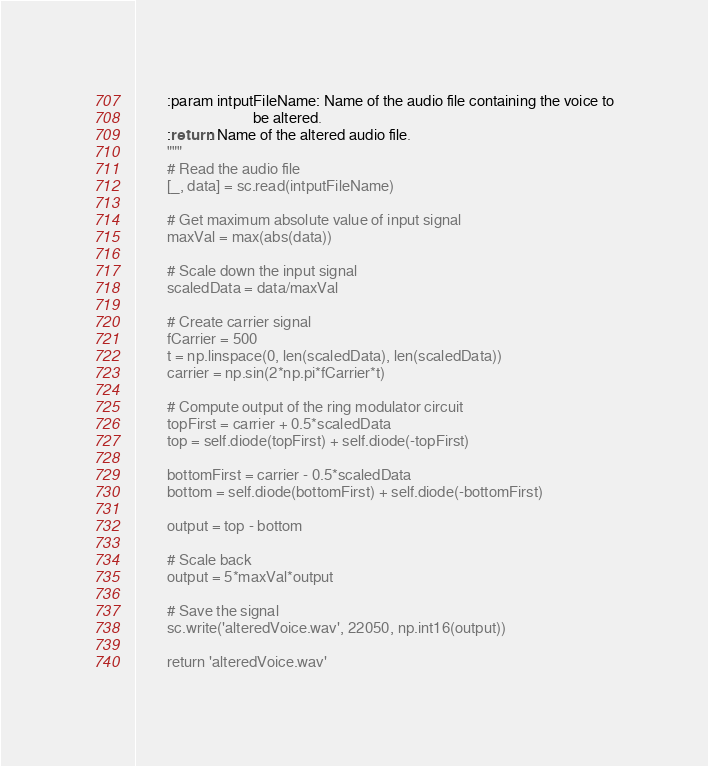Convert code to text. <code><loc_0><loc_0><loc_500><loc_500><_Python_>
        :param intputFileName: Name of the audio file containing the voice to
                               be altered.
        :return: Name of the altered audio file.
        """
        # Read the audio file
        [_, data] = sc.read(intputFileName)

        # Get maximum absolute value of input signal
        maxVal = max(abs(data))

        # Scale down the input signal
        scaledData = data/maxVal

        # Create carrier signal
        fCarrier = 500
        t = np.linspace(0, len(scaledData), len(scaledData))
        carrier = np.sin(2*np.pi*fCarrier*t)

        # Compute output of the ring modulator circuit
        topFirst = carrier + 0.5*scaledData
        top = self.diode(topFirst) + self.diode(-topFirst)

        bottomFirst = carrier - 0.5*scaledData
        bottom = self.diode(bottomFirst) + self.diode(-bottomFirst)

        output = top - bottom

        # Scale back
        output = 5*maxVal*output

        # Save the signal
        sc.write('alteredVoice.wav', 22050, np.int16(output))

        return 'alteredVoice.wav'
</code> 